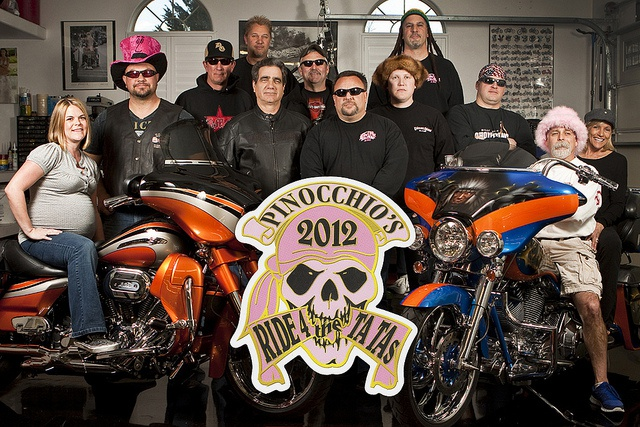Describe the objects in this image and their specific colors. I can see motorcycle in black, maroon, red, and brown tones, motorcycle in black, gray, red, and maroon tones, people in black, lightgray, gray, and darkgray tones, people in black, gray, and maroon tones, and people in black, lightgray, tan, and gray tones in this image. 